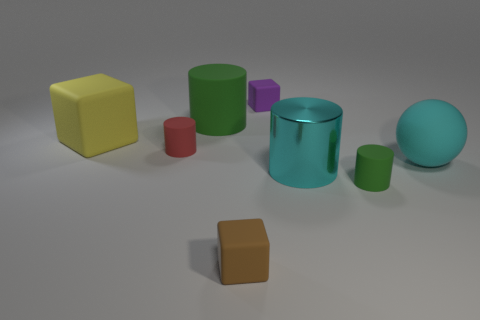What material is the cyan thing that is the same size as the cyan matte sphere?
Provide a succinct answer. Metal. Is the number of big things that are on the right side of the tiny red thing greater than the number of cyan rubber things that are on the left side of the large green rubber cylinder?
Provide a short and direct response. Yes. Are there any tiny yellow rubber things that have the same shape as the large green thing?
Your answer should be compact. No. What is the shape of the yellow rubber object that is the same size as the metal cylinder?
Make the answer very short. Cube. What shape is the green thing in front of the cyan sphere?
Give a very brief answer. Cylinder. Are there fewer big cyan spheres to the left of the big rubber block than large matte things that are left of the shiny object?
Give a very brief answer. Yes. Do the shiny thing and the rubber cube that is on the left side of the large green cylinder have the same size?
Make the answer very short. Yes. What number of balls are the same size as the yellow rubber block?
Provide a succinct answer. 1. The large cube that is made of the same material as the small brown thing is what color?
Give a very brief answer. Yellow. Is the number of rubber cylinders greater than the number of tiny brown matte objects?
Offer a very short reply. Yes. 